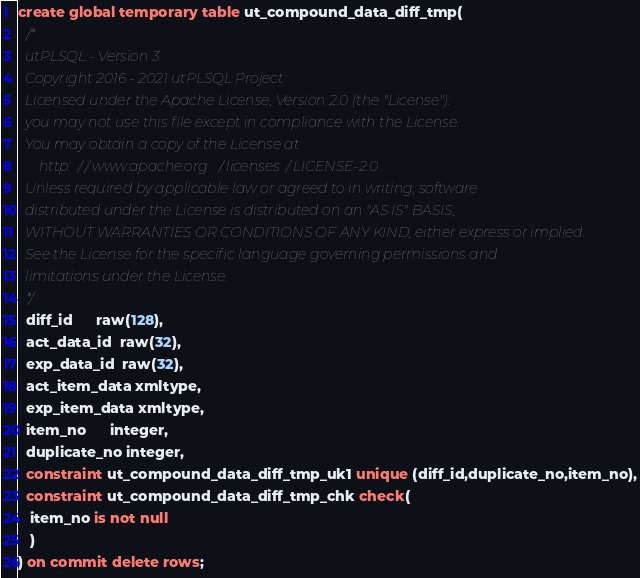<code> <loc_0><loc_0><loc_500><loc_500><_SQL_>create global temporary table ut_compound_data_diff_tmp(
  /*
  utPLSQL - Version 3
  Copyright 2016 - 2021 utPLSQL Project
  Licensed under the Apache License, Version 2.0 (the "License"):
  you may not use this file except in compliance with the License.
  You may obtain a copy of the License at
      http://www.apache.org/licenses/LICENSE-2.0
  Unless required by applicable law or agreed to in writing, software
  distributed under the License is distributed on an "AS IS" BASIS,
  WITHOUT WARRANTIES OR CONDITIONS OF ANY KIND, either express or implied.
  See the License for the specific language governing permissions and
  limitations under the License.
  */
  diff_id      raw(128),
  act_data_id  raw(32),
  exp_data_id  raw(32),
  act_item_data xmltype,
  exp_item_data xmltype,
  item_no      integer,
  duplicate_no integer,
  constraint ut_compound_data_diff_tmp_uk1 unique (diff_id,duplicate_no,item_no),
  constraint ut_compound_data_diff_tmp_chk check(
   item_no is not null
   )
) on commit delete rows;
</code> 